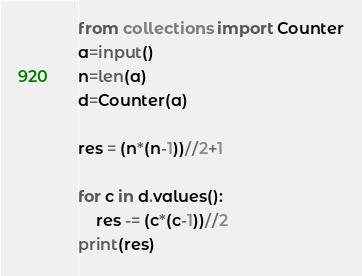Convert code to text. <code><loc_0><loc_0><loc_500><loc_500><_Python_>from collections import Counter
a=input()
n=len(a)
d=Counter(a)

res = (n*(n-1))//2+1

for c in d.values():
    res -= (c*(c-1))//2
print(res)</code> 